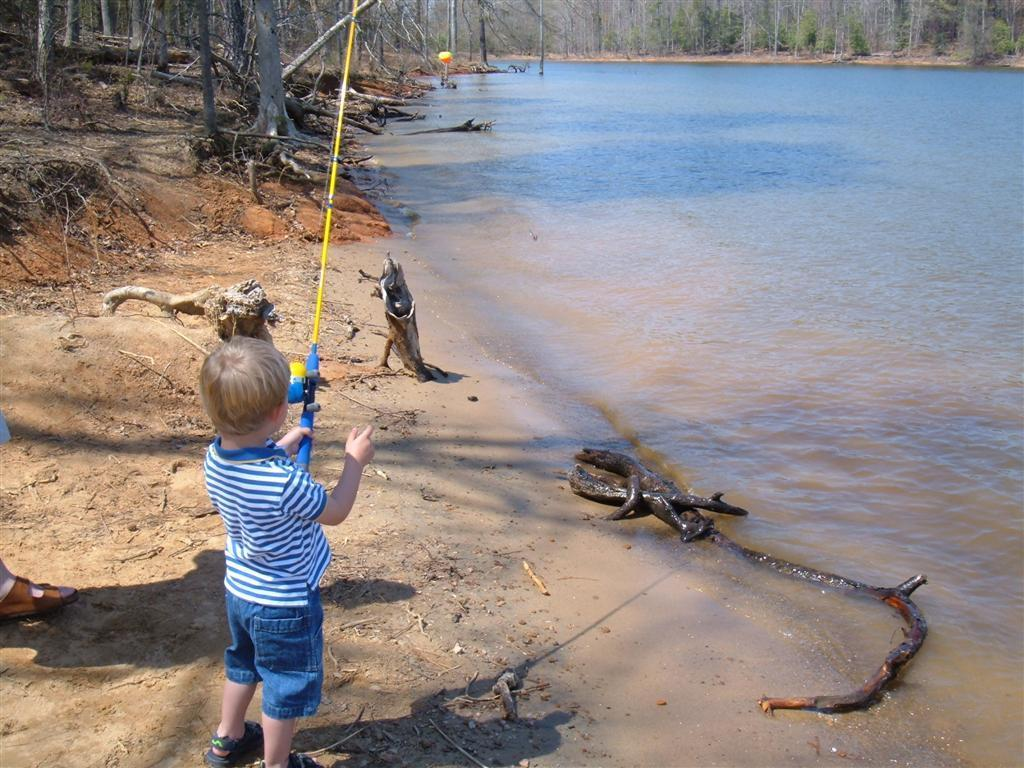What is the main subject of the image? The main subject of the image is a boy. What is the boy holding in the image? The boy is holding an object. What type of natural environment is visible in the image? There is sand, a river, and trees visible in the image. What type of lip product is the boy applying in the image? There is no lip product or application visible in the image. What type of silk garment is the boy wearing in the image? There is no silk garment visible in the image. What type of educational institution is present in the image? There is no educational institution present in the image. 